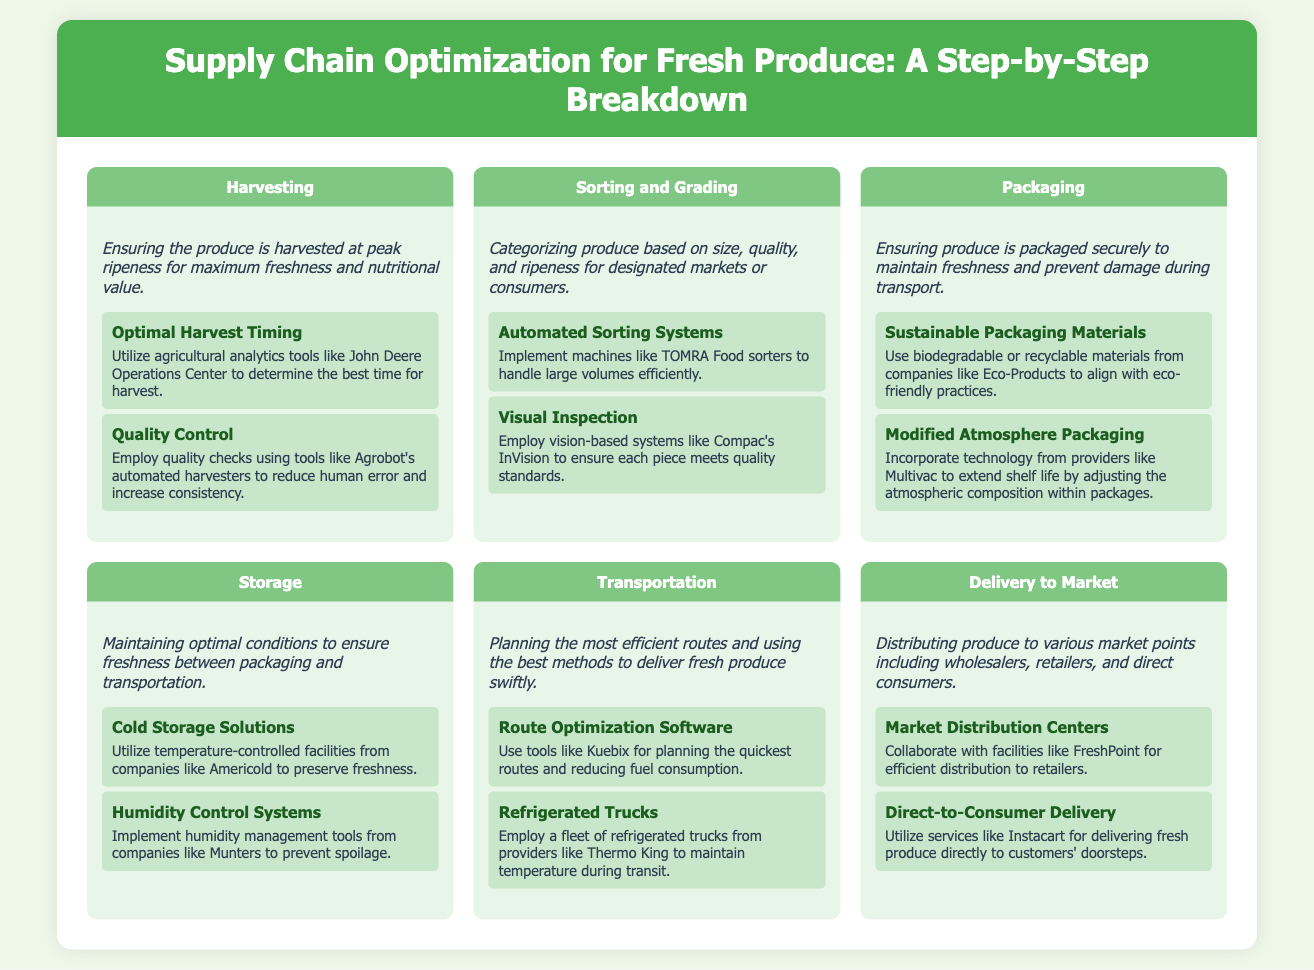what is the first phase of the supply chain? The first phase listed in the infographic is the one where produce is harvested at peak ripeness.
Answer: Harvesting what technology is suggested for optimal harvest timing? The document mentions utilizing agricultural analytics tools to determine the best time for harvest.
Answer: John Deere Operations Center which material type is recommended for sustainable packaging? The infographic suggests using eco-friendly materials that are biodegradable or recyclable.
Answer: Biodegradable or recyclable what is the main purpose of cold storage solutions? The reason for using cold storage solutions is to preserve the freshness of the produce.
Answer: Preserve freshness which company provides refrigerated trucks? This company is mentioned in the transportation phase for maintaining temperature during transit.
Answer: Thermo King what is the last phase in the supply chain? The final phase detailed in the infographic is about distributing produce to market points.
Answer: Delivery to Market what does Modified Atmosphere Packaging extend? The technology mentioned is aimed at prolonging the freshness of the produce inside packages.
Answer: Shelf life what is the role of route optimization software? The document explains that it helps in planning the quickest routes and reducing fuel consumption.
Answer: Planning quickest routes what is the purpose of humidity control systems? These systems are designed to prevent spoilage during the storage phase of the supply chain.
Answer: Prevent spoilage 